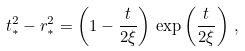<formula> <loc_0><loc_0><loc_500><loc_500>t _ { * } ^ { 2 } - r _ { * } ^ { 2 } = \left ( 1 - \frac { t } { 2 \xi } \right ) \, \exp \left ( \frac { t } { 2 \xi } \right ) \, ,</formula> 